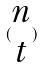Convert formula to latex. <formula><loc_0><loc_0><loc_500><loc_500>( \begin{matrix} n \\ t \end{matrix} )</formula> 